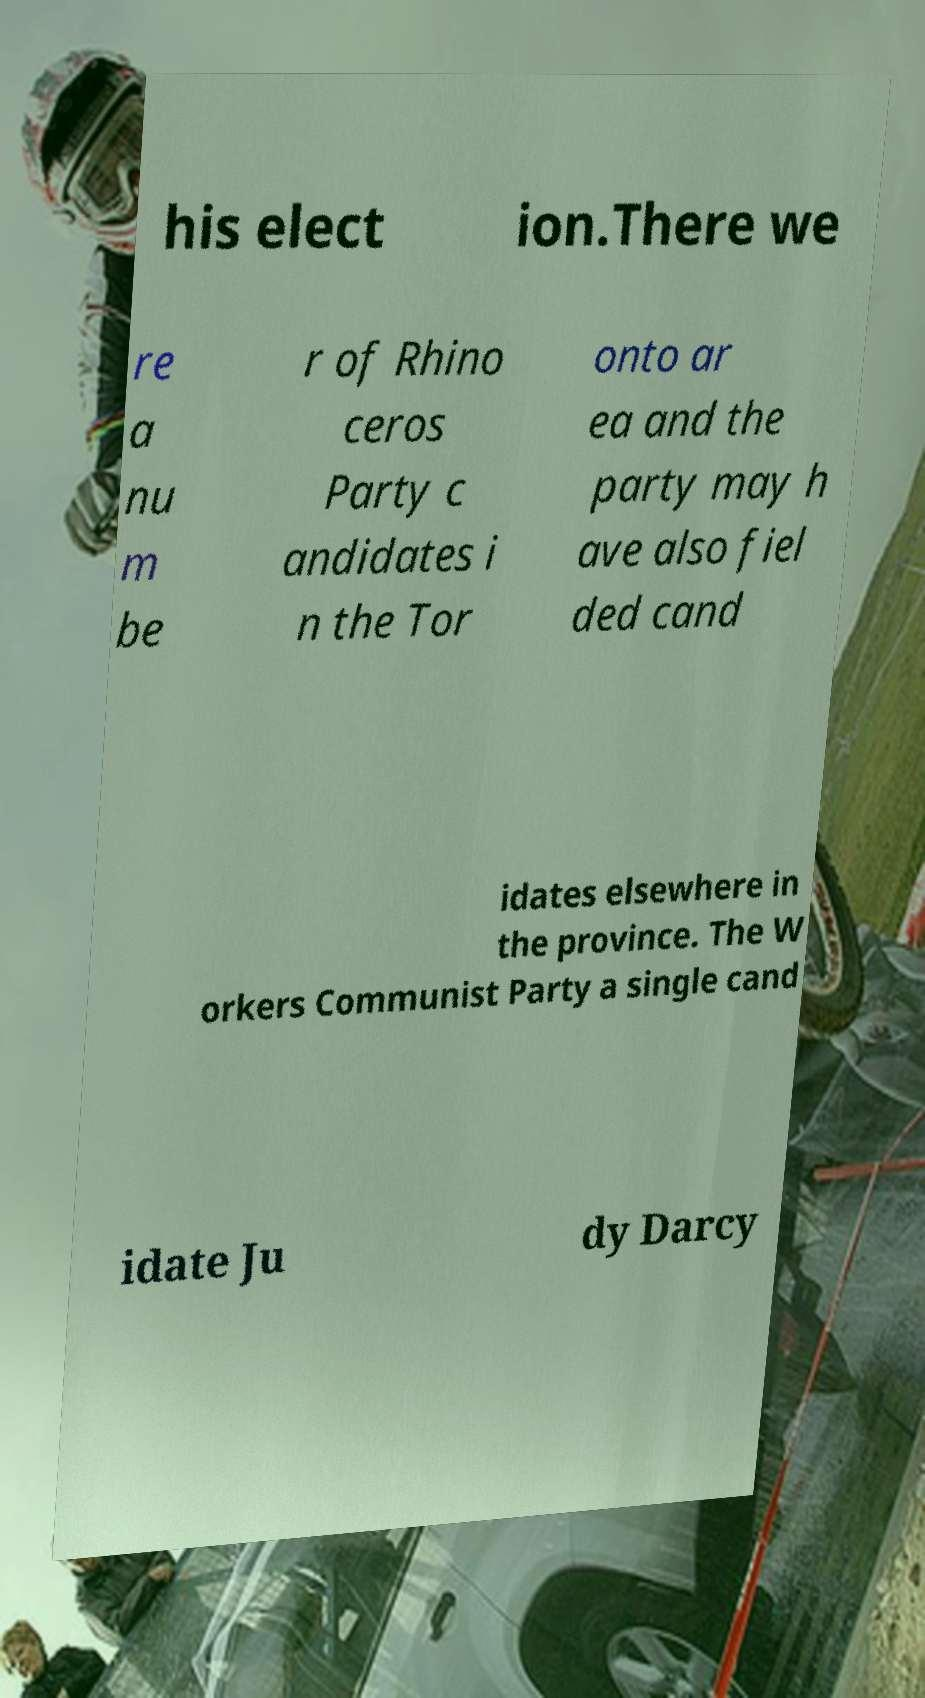There's text embedded in this image that I need extracted. Can you transcribe it verbatim? his elect ion.There we re a nu m be r of Rhino ceros Party c andidates i n the Tor onto ar ea and the party may h ave also fiel ded cand idates elsewhere in the province. The W orkers Communist Party a single cand idate Ju dy Darcy 